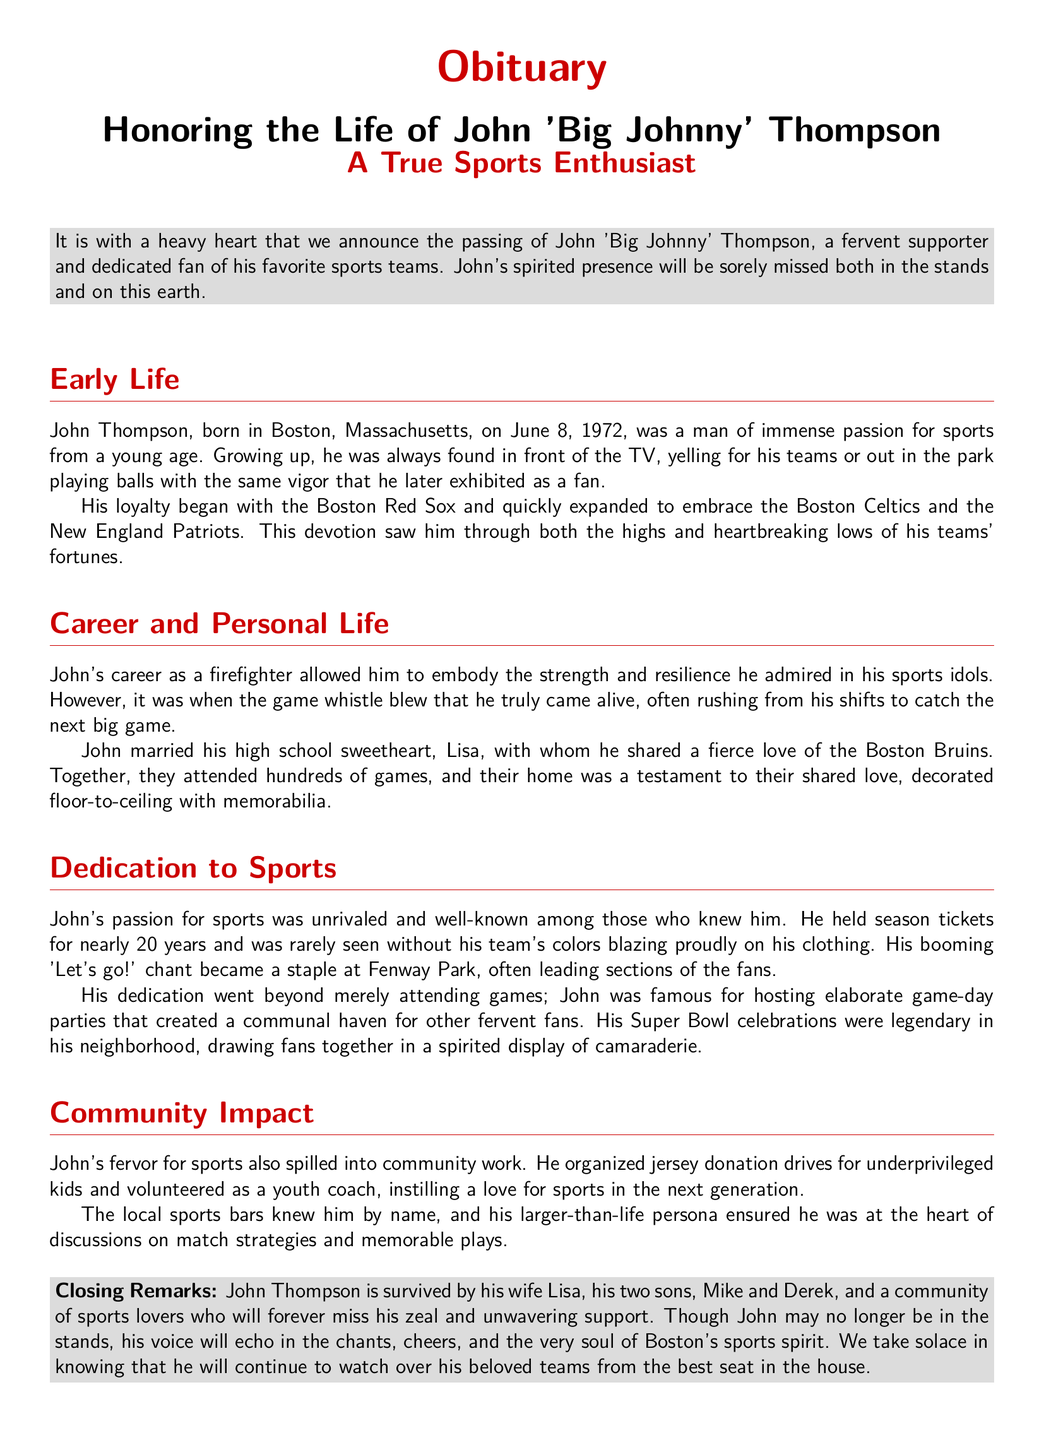What was John Thompson's nickname? The document refers to him as 'Big Johnny'.
Answer: 'Big Johnny' When was John Thompson born? His birthdate is mentioned in the document as June 8, 1972.
Answer: June 8, 1972 Which teams did John support? The document lists the Boston Red Sox, Boston Celtics, and New England Patriots among his favorite teams.
Answer: Boston Red Sox, Boston Celtics, New England Patriots What profession did John Thompson have? The document states he was a firefighter.
Answer: Firefighter How long did John hold season tickets? The document mentions he held season tickets for nearly 20 years.
Answer: Nearly 20 years Who did John marry? The document indicates he married his high school sweetheart, Lisa.
Answer: Lisa What was a notable aspect of John's Super Bowl celebrations? The document describes his Super Bowl celebrations as legendary and drawing fans together.
Answer: Legendary What community activity did John participate in? He organized jersey donation drives for underprivileged kids.
Answer: Jersey donation drives How many children did John have? The document states that he is survived by two sons.
Answer: Two sons 